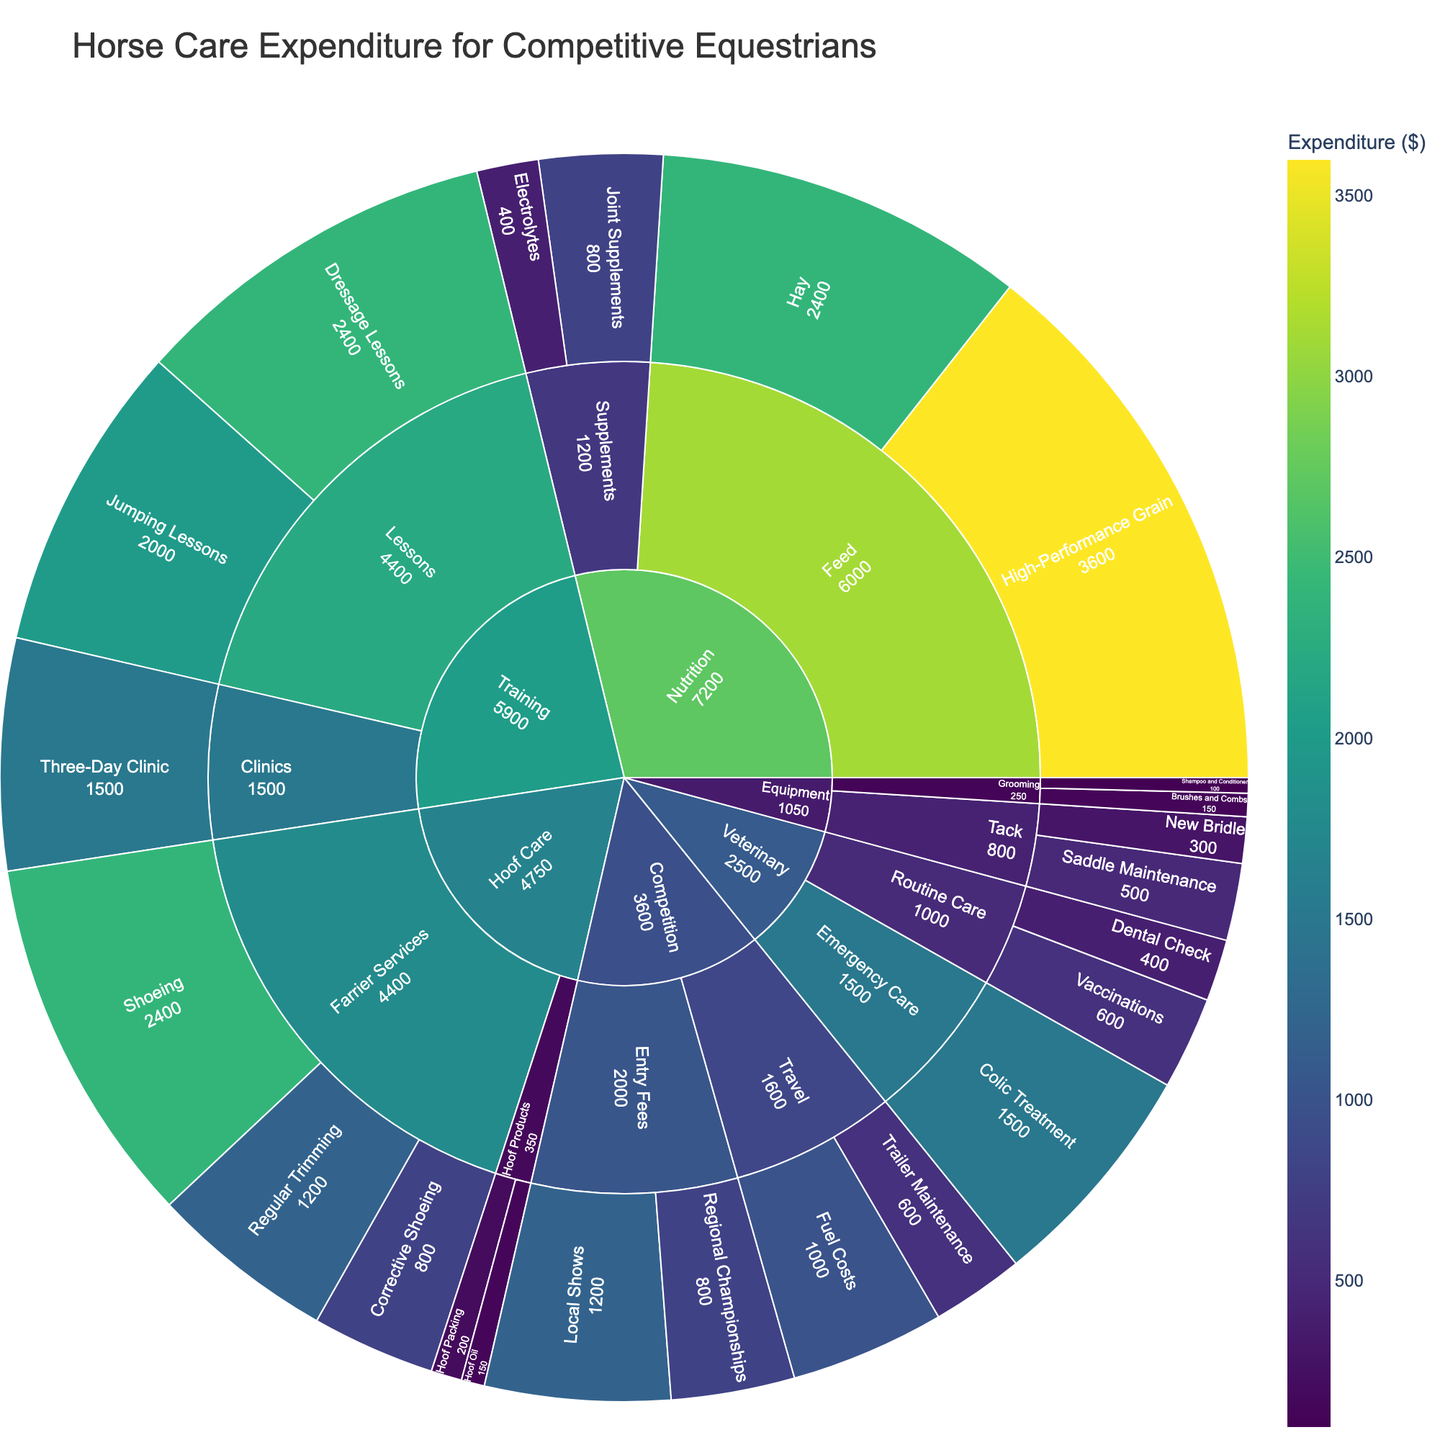What's the title of the Sunburst Plot? The title is located at the top part of the figure and it provides a summary of what the plot represents. By looking at that area, we can find the title text.
Answer: Horse Care Expenditure for Competitive Equestrians Which category has the highest expenditure? The category with the largest segment and the most intense color reflects the highest expenditure. By examining these segments, we can see which is the highest.
Answer: Nutrition What is the total expenditure on Farrier Services? To find the total expenditure on Farrier Services, look for the relevant segments under the Hoof Care category and sum the values given for Regular Trimming, Shoeing, and Corrective Shoeing.
Answer: 1200 + 2400 + 800 = 4400 How does the expenditure on Shoeing compare to Corrective Shoeing? Compare the values for the Shoeing and Corrective Shoeing segments within the Farrier Services subcategory.
Answer: Shoeing is significantly higher at 2400 compared to 800 for Corrective Shoeing What is the smallest expense item under the Veterinary category? To determine the smallest expense, inspect the segments within the Veterinary category and identify the segment with the smallest value.
Answer: Dental Check Which subcategory has the highest expenditure in the Training category? Check the segments within the Training category and identify which subcategory (Lessons or Clinics) has the highest cumulative expenditure.
Answer: Lessons What is the total expenditure for the Hoof Products subcategory? Sum the expenditures for Hoof Oil and Hoof Packing, which are the items under the Hoof Products subcategory in the Hoof Care category.
Answer: 150 + 200 = 350 Is the expenditure on Local Show Entry Fees more than Regional Championships Entry Fees? Compare the values of the segments for Local Shows and Regional Championships under the Entry Fees subcategory in the Competition category.
Answer: Yes, 1200 > 800 What is the combined expenditure for Fuel Costs and Trailer Maintenance under Travel? Add the expenditures for Fuel Costs and Trailer Maintenance, which are under the Travel subcategory in the Competition category.
Answer: 1000 + 600 = 1600 Which item has the highest expenditure in the Nutrition category? Examine the items within the Nutrition category and identify the one with the highest expenditure value.
Answer: High-Performance Grain 